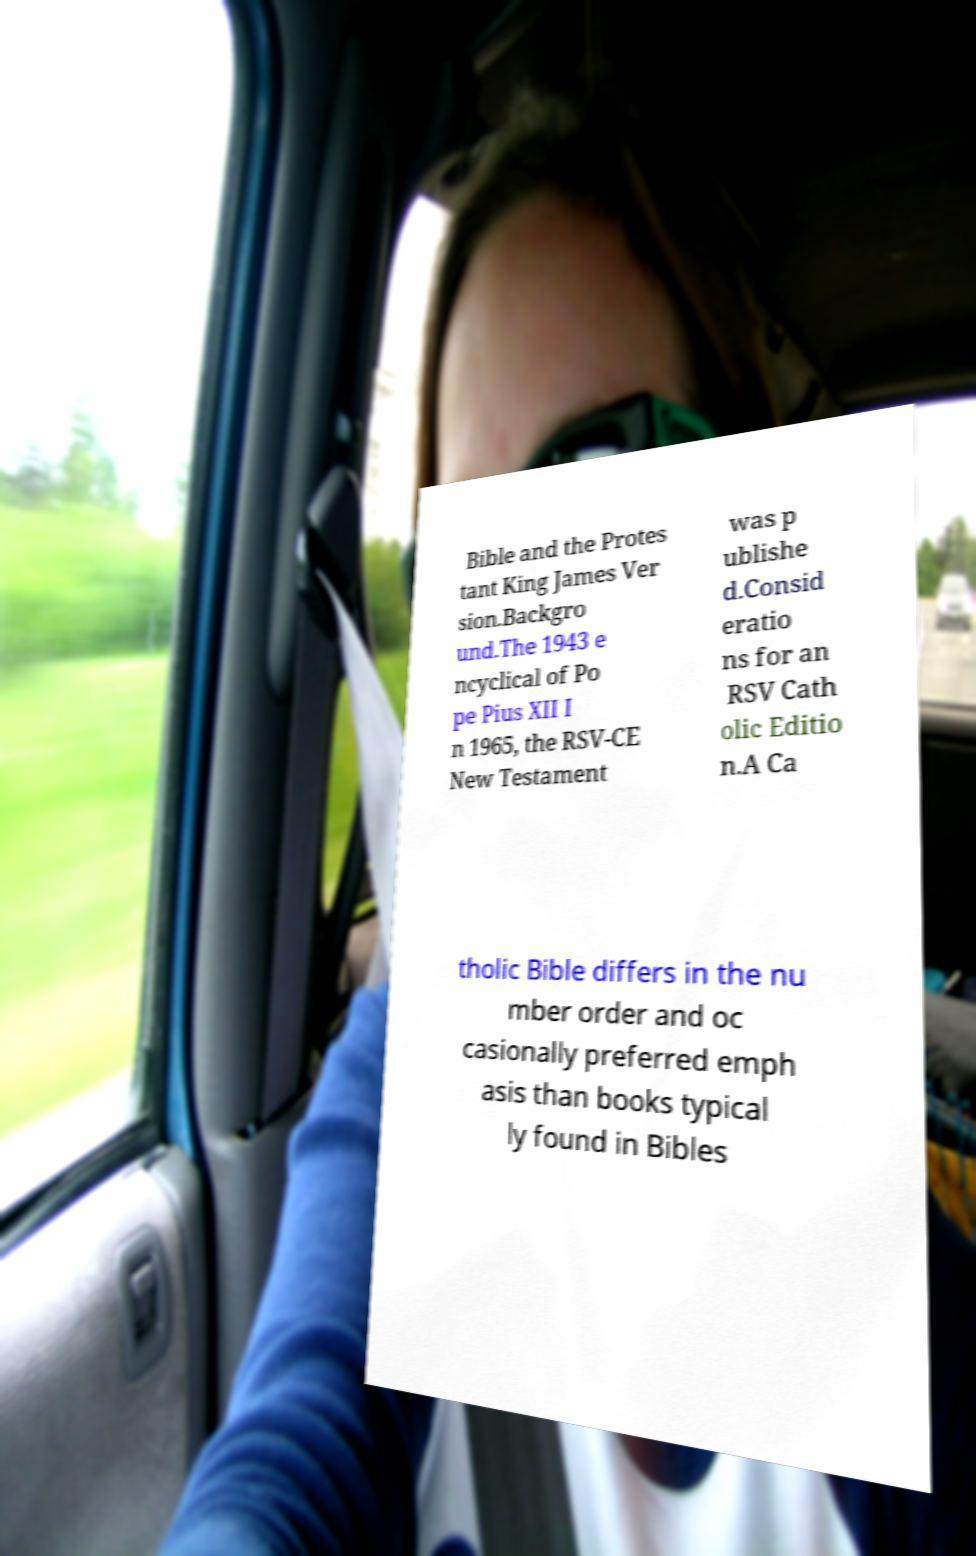Please read and relay the text visible in this image. What does it say? Bible and the Protes tant King James Ver sion.Backgro und.The 1943 e ncyclical of Po pe Pius XII I n 1965, the RSV-CE New Testament was p ublishe d.Consid eratio ns for an RSV Cath olic Editio n.A Ca tholic Bible differs in the nu mber order and oc casionally preferred emph asis than books typical ly found in Bibles 